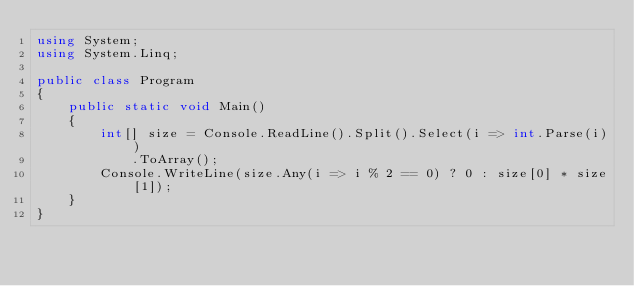<code> <loc_0><loc_0><loc_500><loc_500><_C#_>using System;
using System.Linq;

public class Program
{
	public static void Main()
	{
		int[] size = Console.ReadLine().Split().Select(i => int.Parse(i))
			.ToArray();
		Console.WriteLine(size.Any(i => i % 2 == 0) ? 0 : size[0] * size[1]);
	}
}</code> 